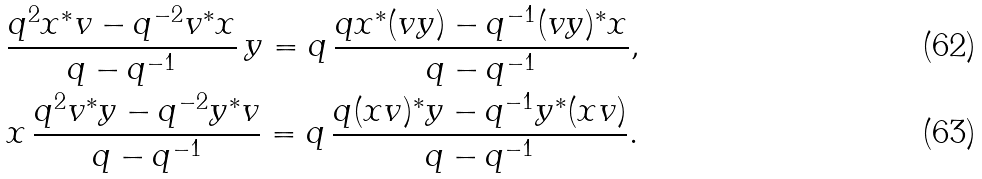<formula> <loc_0><loc_0><loc_500><loc_500>& \frac { q ^ { 2 } x ^ { * } v - q ^ { - 2 } v ^ { * } x } { q - q ^ { - 1 } } \, y = q \, \frac { q x ^ { * } ( v y ) - q ^ { - 1 } ( v y ) ^ { * } x } { q - q ^ { - 1 } } , \\ & x \, \frac { q ^ { 2 } v ^ { * } y - q ^ { - 2 } y ^ { * } v } { q - q ^ { - 1 } } = q \, \frac { q ( x v ) ^ { * } y - q ^ { - 1 } y ^ { * } ( x v ) } { q - q ^ { - 1 } } .</formula> 